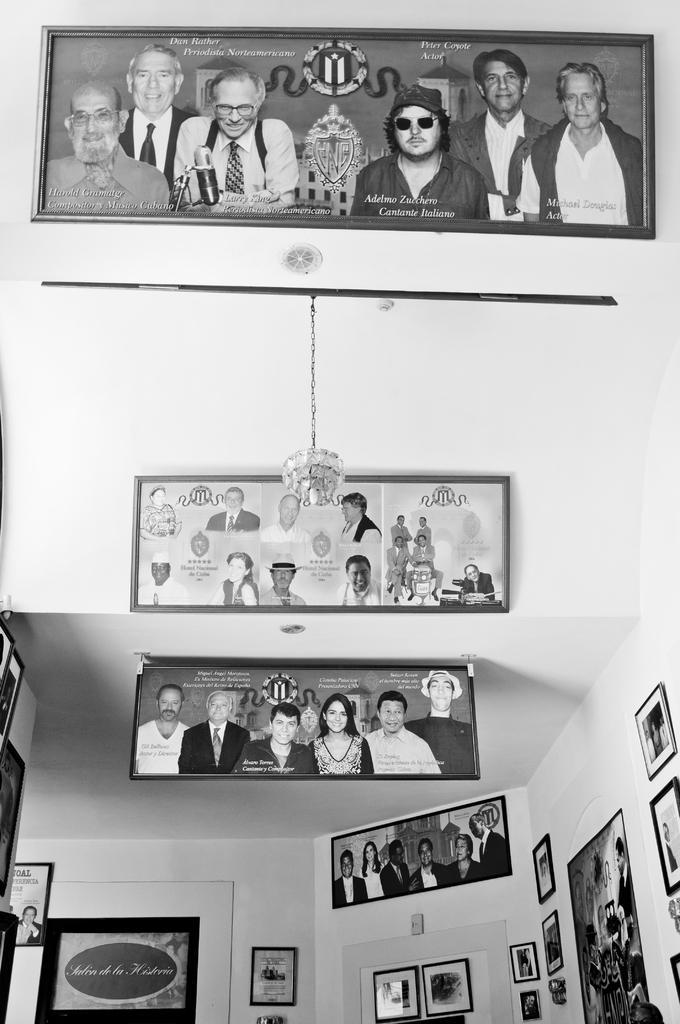Describe this image in one or two sentences. In this image it looks like inside of the building. And there is a wall, on that wall there are photo frames attached to it. And there is a light attached to the rod. 